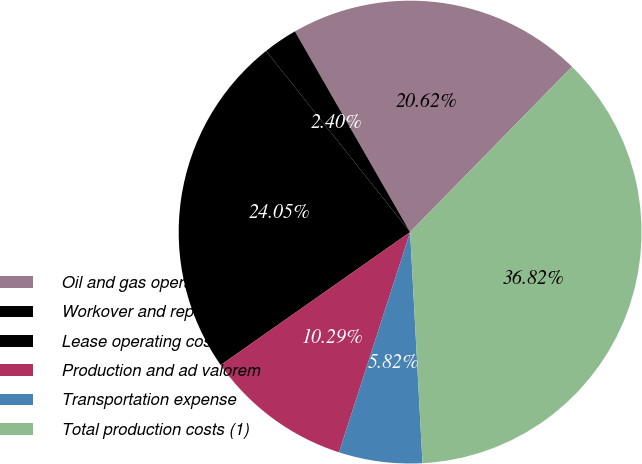Convert chart. <chart><loc_0><loc_0><loc_500><loc_500><pie_chart><fcel>Oil and gas operating costs<fcel>Workover and repair expense<fcel>Lease operating costs<fcel>Production and ad valorem<fcel>Transportation expense<fcel>Total production costs (1)<nl><fcel>20.62%<fcel>2.4%<fcel>24.05%<fcel>10.29%<fcel>5.82%<fcel>36.82%<nl></chart> 